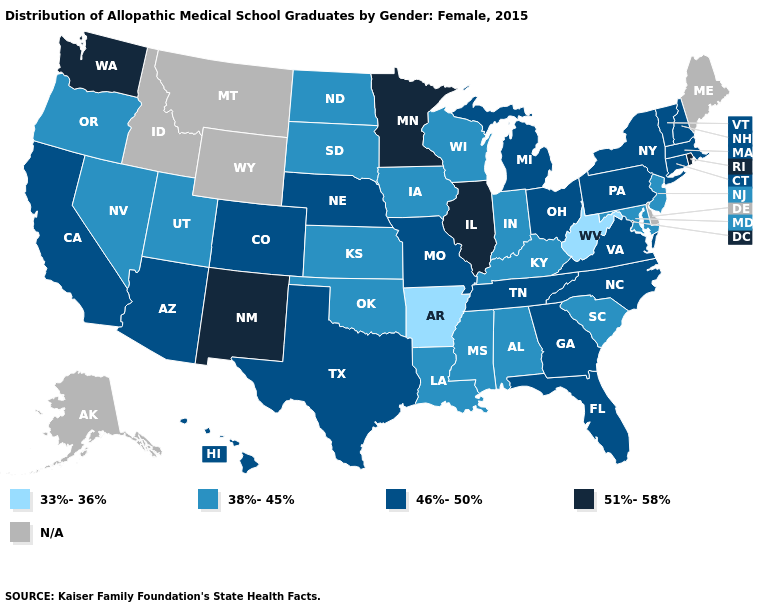Name the states that have a value in the range N/A?
Give a very brief answer. Alaska, Delaware, Idaho, Maine, Montana, Wyoming. What is the highest value in the USA?
Keep it brief. 51%-58%. How many symbols are there in the legend?
Give a very brief answer. 5. Name the states that have a value in the range N/A?
Write a very short answer. Alaska, Delaware, Idaho, Maine, Montana, Wyoming. Which states have the highest value in the USA?
Give a very brief answer. Illinois, Minnesota, New Mexico, Rhode Island, Washington. What is the highest value in the MidWest ?
Give a very brief answer. 51%-58%. Among the states that border Indiana , does Michigan have the highest value?
Answer briefly. No. What is the value of Virginia?
Be succinct. 46%-50%. Does Colorado have the lowest value in the USA?
Keep it brief. No. Is the legend a continuous bar?
Write a very short answer. No. Name the states that have a value in the range 38%-45%?
Quick response, please. Alabama, Indiana, Iowa, Kansas, Kentucky, Louisiana, Maryland, Mississippi, Nevada, New Jersey, North Dakota, Oklahoma, Oregon, South Carolina, South Dakota, Utah, Wisconsin. Name the states that have a value in the range 33%-36%?
Be succinct. Arkansas, West Virginia. Which states have the lowest value in the USA?
Concise answer only. Arkansas, West Virginia. Name the states that have a value in the range 33%-36%?
Answer briefly. Arkansas, West Virginia. 